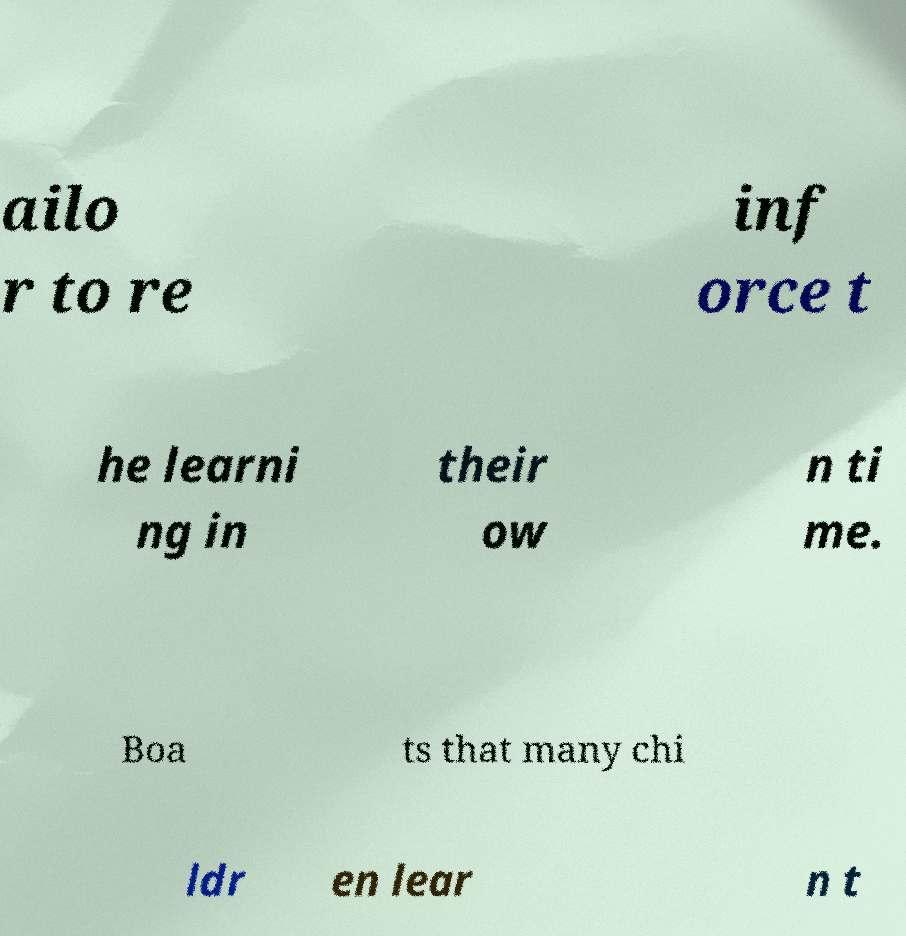Can you read and provide the text displayed in the image?This photo seems to have some interesting text. Can you extract and type it out for me? ailo r to re inf orce t he learni ng in their ow n ti me. Boa ts that many chi ldr en lear n t 